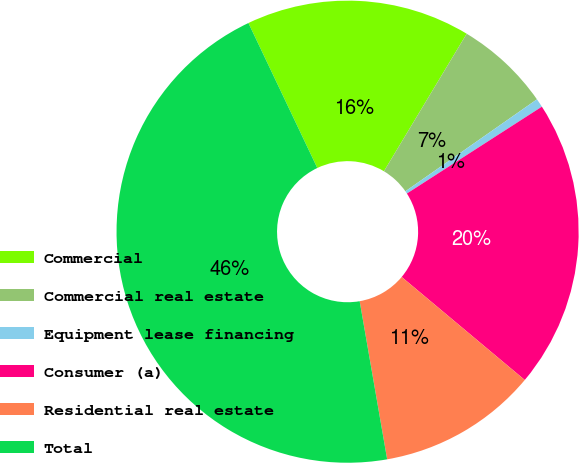Convert chart. <chart><loc_0><loc_0><loc_500><loc_500><pie_chart><fcel>Commercial<fcel>Commercial real estate<fcel>Equipment lease financing<fcel>Consumer (a)<fcel>Residential real estate<fcel>Total<nl><fcel>15.68%<fcel>6.67%<fcel>0.61%<fcel>20.19%<fcel>11.17%<fcel>45.68%<nl></chart> 